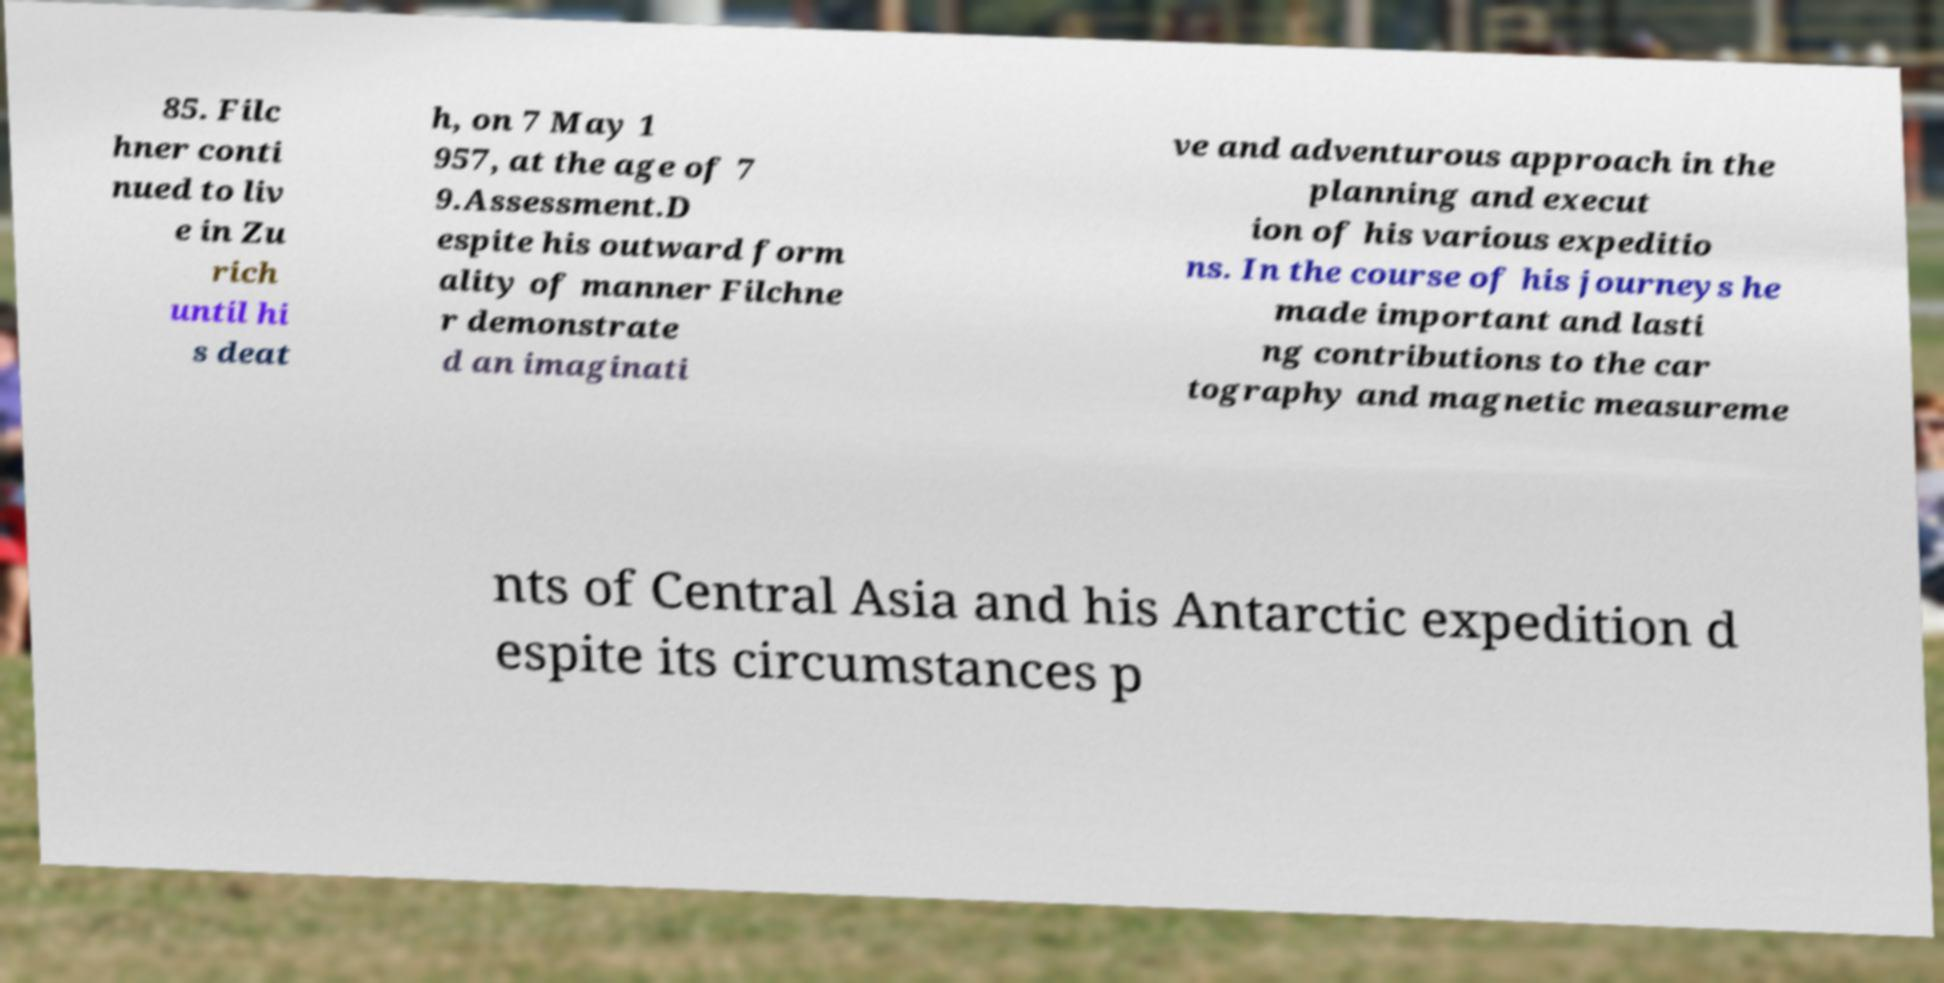For documentation purposes, I need the text within this image transcribed. Could you provide that? 85. Filc hner conti nued to liv e in Zu rich until hi s deat h, on 7 May 1 957, at the age of 7 9.Assessment.D espite his outward form ality of manner Filchne r demonstrate d an imaginati ve and adventurous approach in the planning and execut ion of his various expeditio ns. In the course of his journeys he made important and lasti ng contributions to the car tography and magnetic measureme nts of Central Asia and his Antarctic expedition d espite its circumstances p 